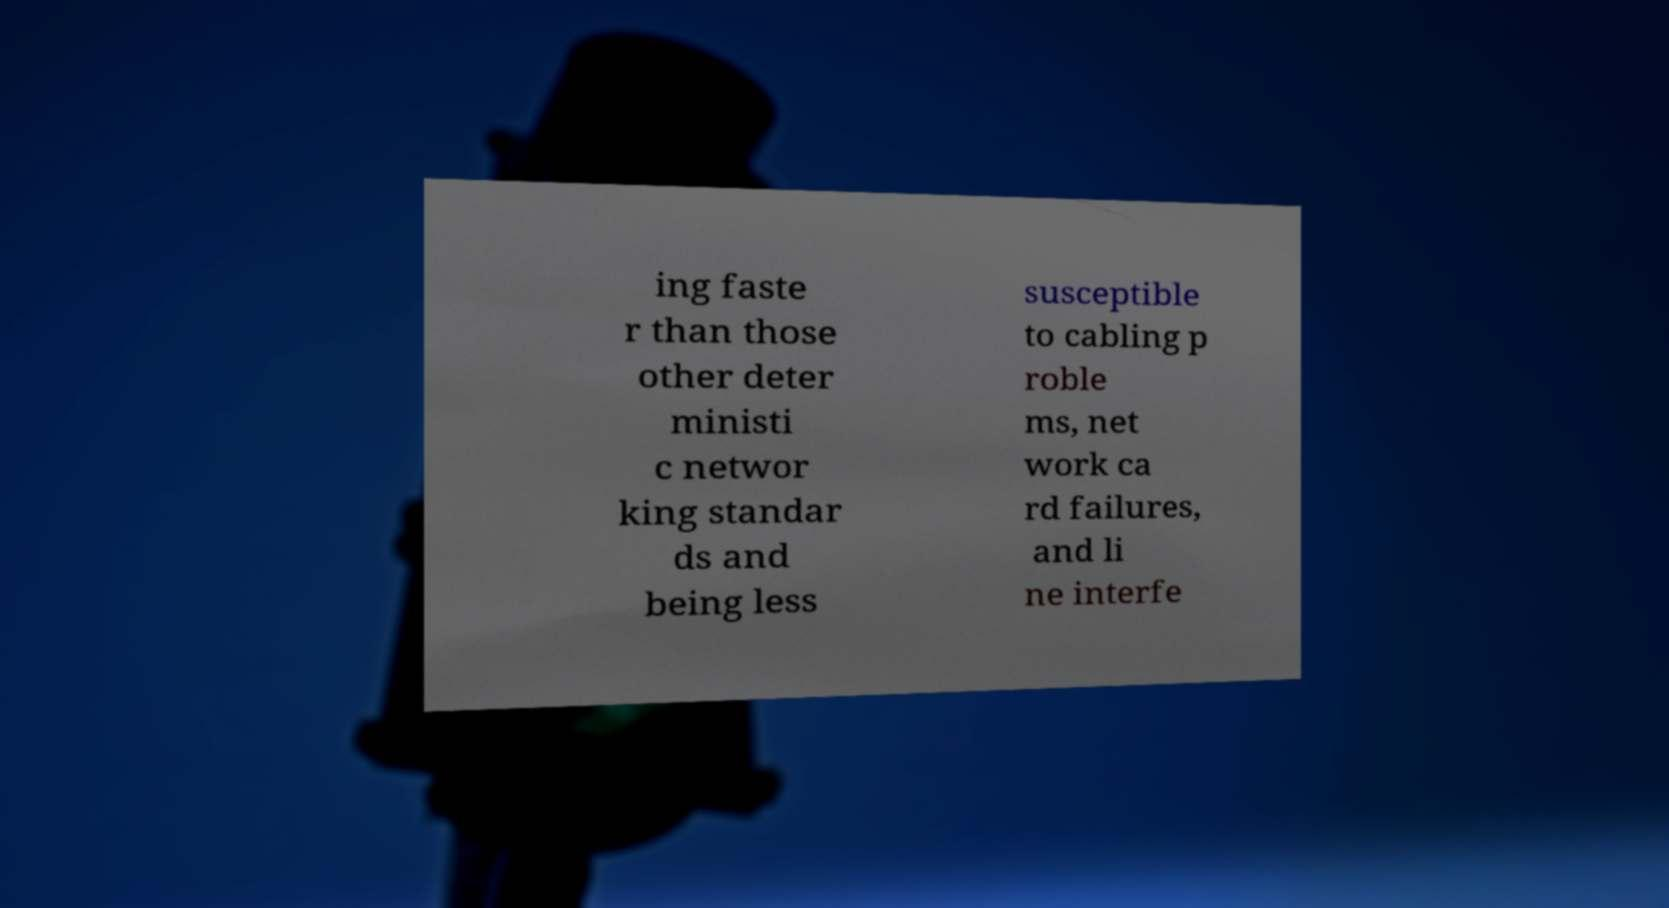What messages or text are displayed in this image? I need them in a readable, typed format. ing faste r than those other deter ministi c networ king standar ds and being less susceptible to cabling p roble ms, net work ca rd failures, and li ne interfe 